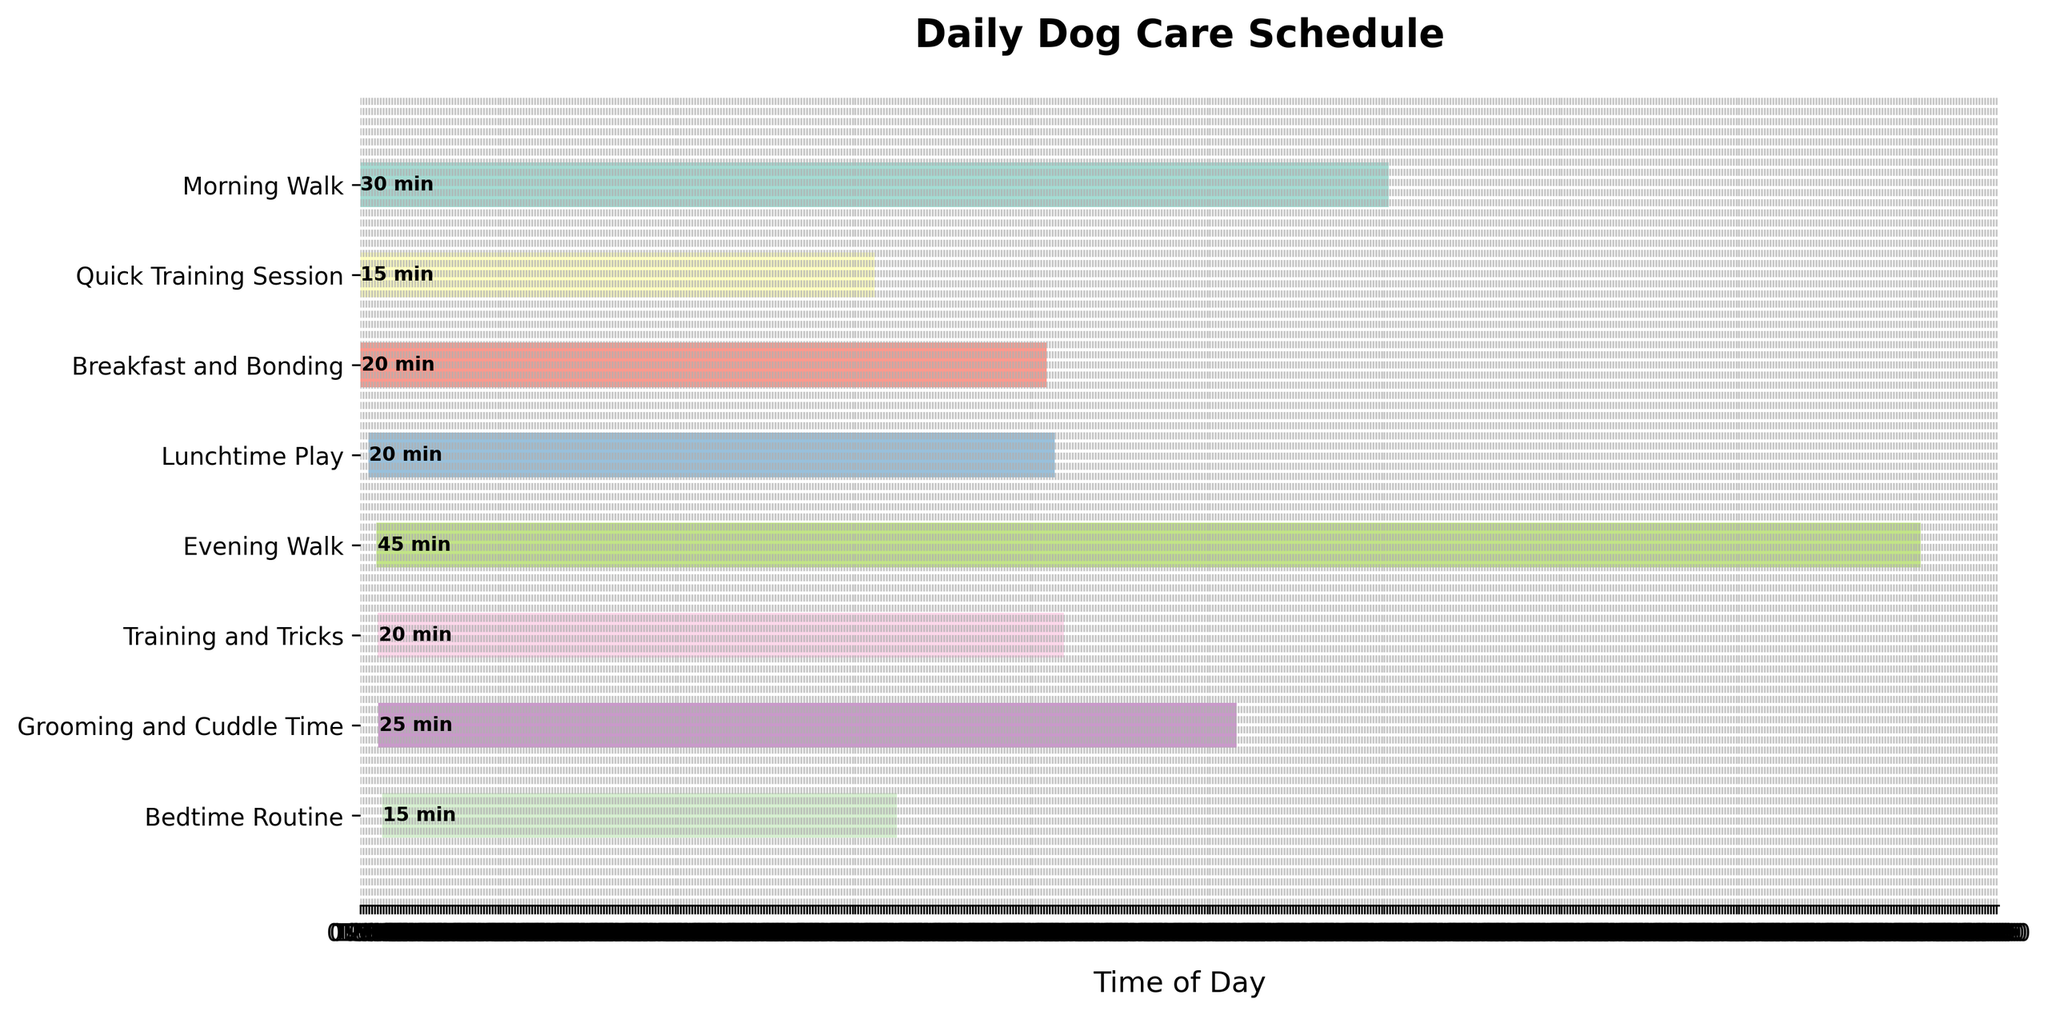What's the title of the figure? The title is usually placed at the top of the figure in larger, bold font. The title for this figure is "Daily Dog Care Schedule".
Answer: Daily Dog Care Schedule What is the earliest task on the schedule? The y-axis lists the tasks, and the x-axis represents the time of the day. The first bar (earliest start) is for "Morning Walk," which starts at 06:00.
Answer: Morning Walk Which task takes the longest duration to complete? By looking at the length of the bars, the "Evening Walk" is the longest as it extends the most along the x-axis. It lasts for 45 minutes.
Answer: Evening Walk How many tasks are scheduled before noon? The x-axis indicates time of day. The tasks before 12:00 are "Morning Walk," "Quick Training Session," and "Breakfast and Bonding." Therefore, there are three tasks before noon.
Answer: 3 What's the total duration spent on walking the dog? Sum up the durations for "Morning Walk" (30 minutes) and "Evening Walk" (45 minutes). The total is 30 + 45 = 75 minutes.
Answer: 75 minutes Which tasks overlap or are closest together in time? Tasks that are close to each other on the x-axis overlap or are close together. "Quick Training Session" (06:30-06:45) starts immediately after "Morning Walk" (06:00-06:30), so they are closest together.
Answer: Morning Walk and Quick Training Session How much time is spent on training related activities? Sum the durations for "Quick Training Session" (15 minutes) and "Training and Tricks" (20 minutes). The total is 15 + 20 = 35 minutes.
Answer: 35 minutes Which activity is scheduled directly after the "Evening Walk"? After the "Evening Walk" (ends at 18:45), the next bar starts at 19:00 for "Training and Tricks".
Answer: Training and Tricks Which tasks are scheduled after 6 PM? Identify the tasks starting after 18:00. These are "Evening Walk," "Training and Tricks," "Grooming and Cuddle Time," and "Bedtime Routine."
Answer: Evening Walk, Training and Tricks, Grooming and Cuddle Time, Bedtime Routine How many training sessions are there throughout the day? The tasks related to training include "Quick Training Session" and "Training and Tricks," which means there are 2 training sessions.
Answer: 2 